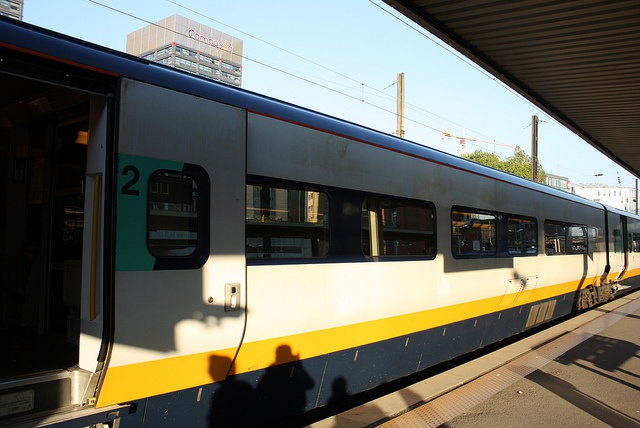Describe the objects in this image and their specific colors. I can see a train in gray, black, purple, beige, and gold tones in this image. 